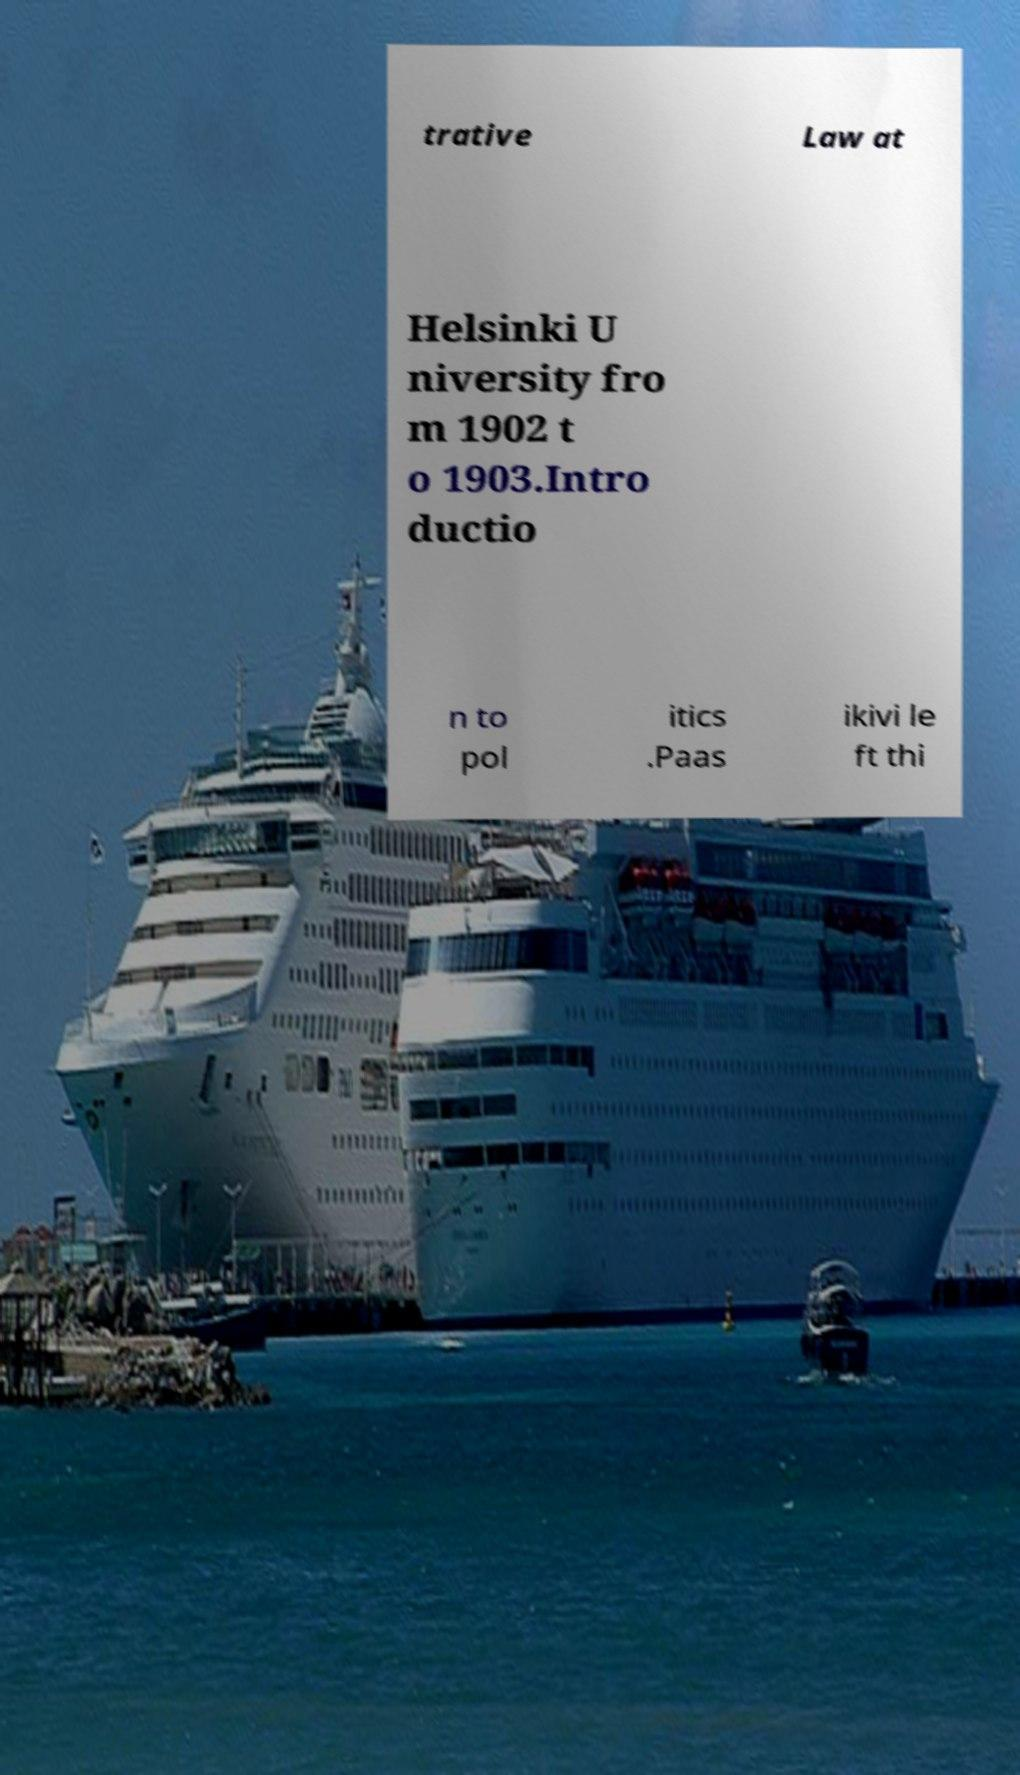I need the written content from this picture converted into text. Can you do that? trative Law at Helsinki U niversity fro m 1902 t o 1903.Intro ductio n to pol itics .Paas ikivi le ft thi 